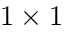<formula> <loc_0><loc_0><loc_500><loc_500>1 \times 1</formula> 